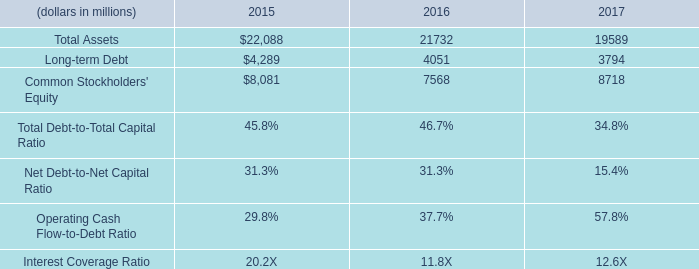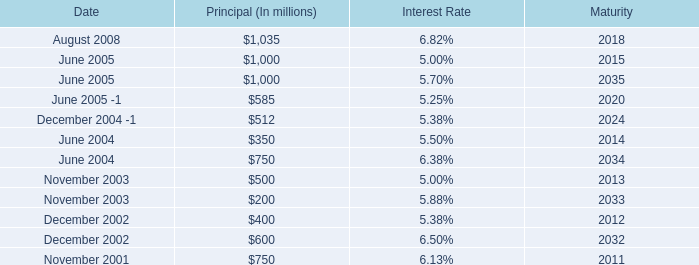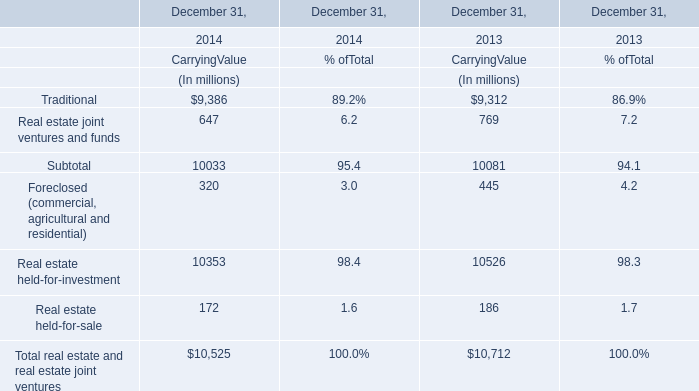The Real estate held-for-investment at Carrying Value of December 31,which year is higher? 
Answer: 2013. 